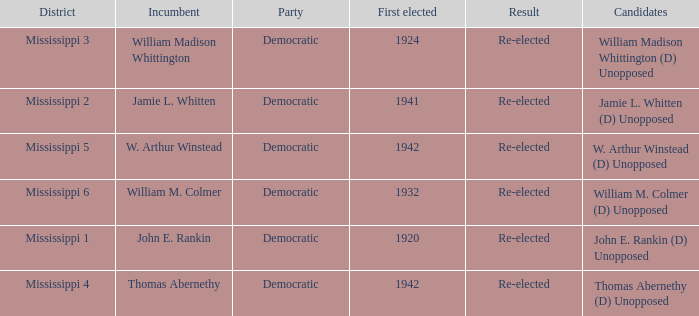Which district is jamie l. whitten from? Mississippi 2. 